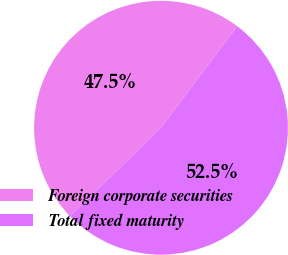Convert chart. <chart><loc_0><loc_0><loc_500><loc_500><pie_chart><fcel>Foreign corporate securities<fcel>Total fixed maturity<nl><fcel>47.53%<fcel>52.47%<nl></chart> 